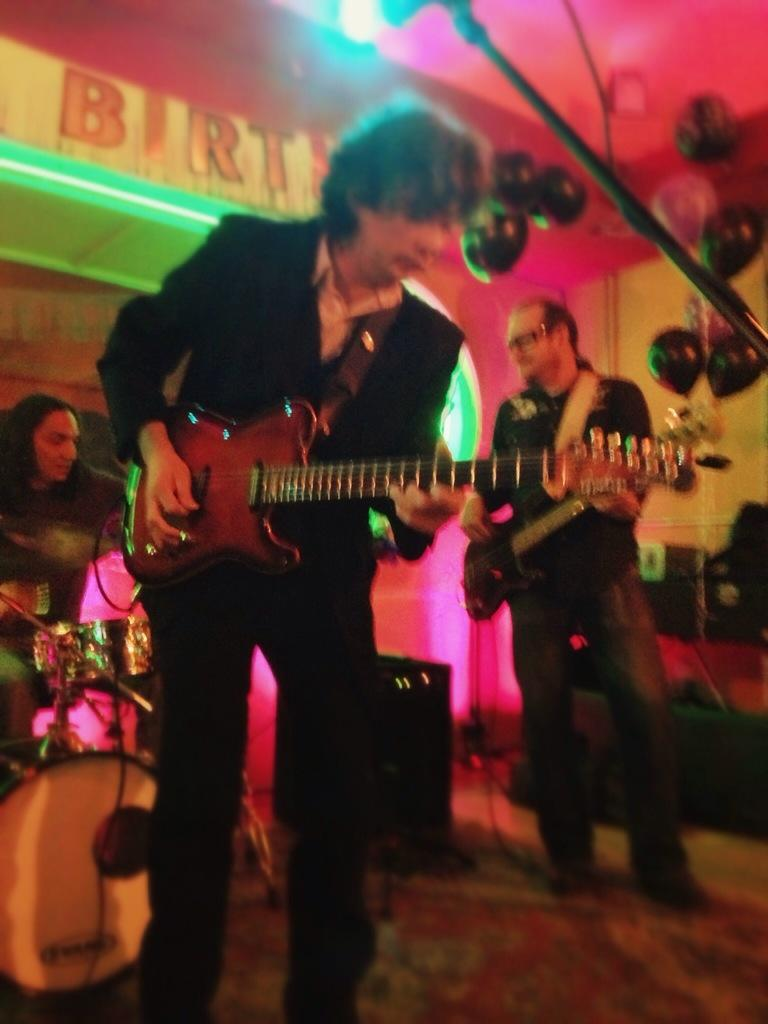What is the person in the foreground of the image wearing? The person in the foreground is wearing a black dress. What is the person in the foreground doing? The person in the foreground is playing a guitar. Can you describe the person in the background of the image? The person in the background is playing drums. What type of steam can be seen coming from the potato in the image? There is no potato or steam present in the image. 